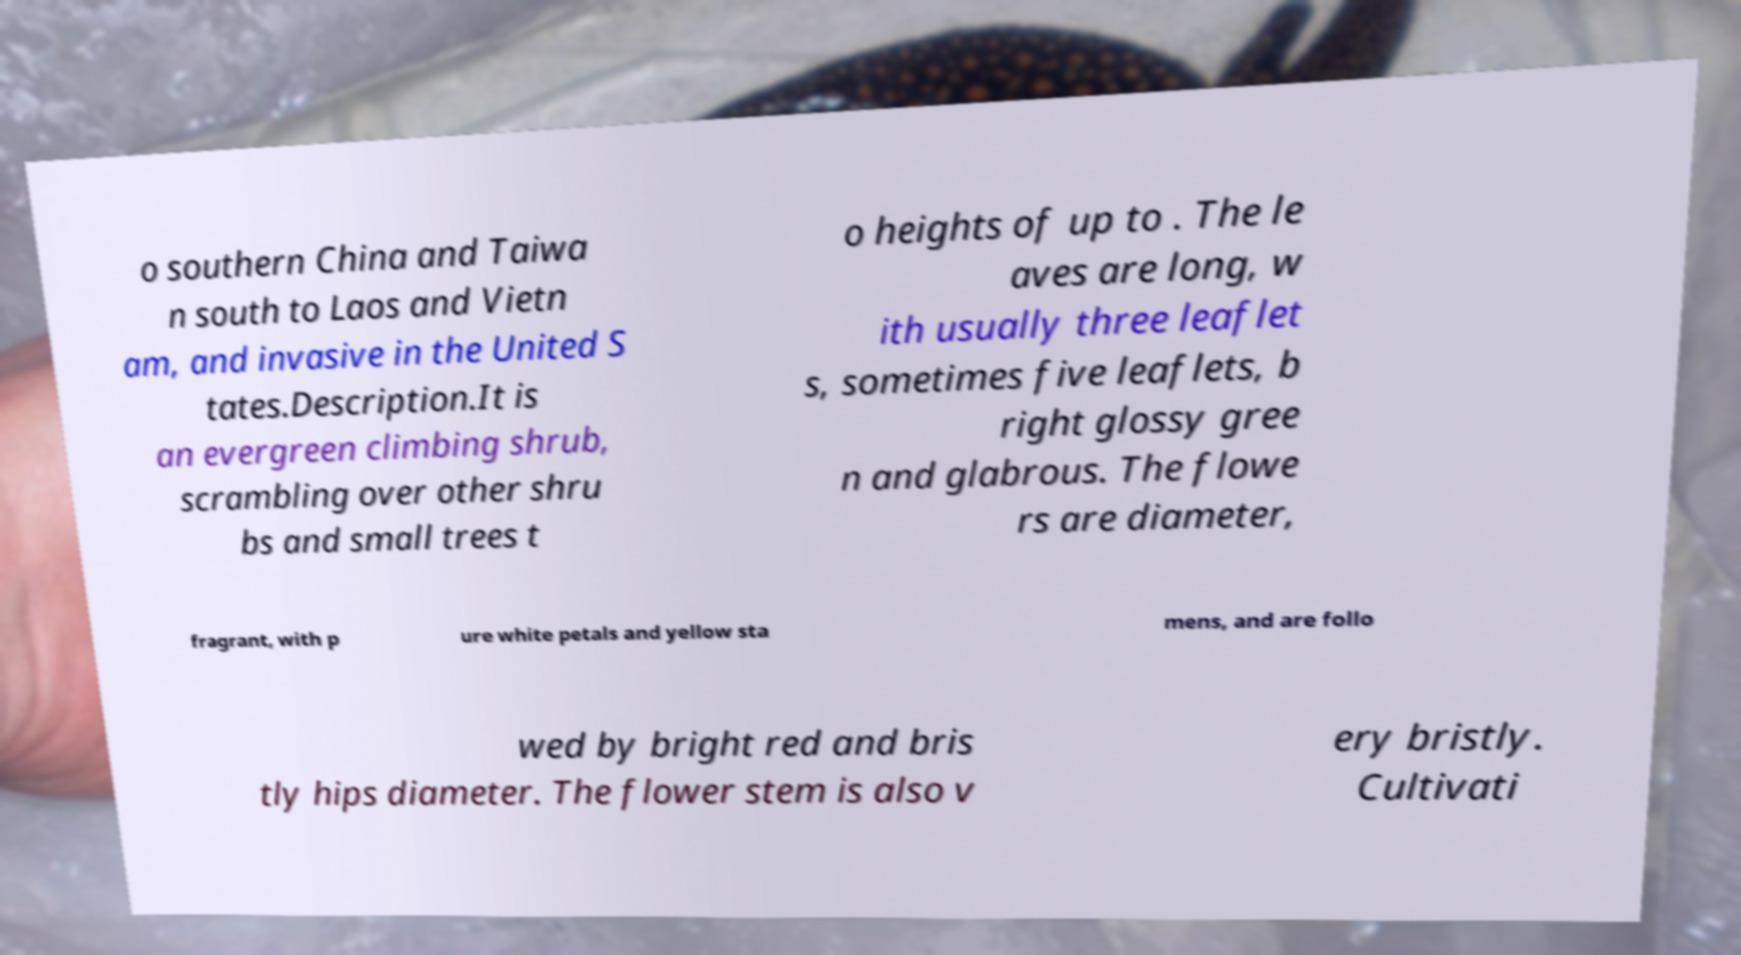Could you assist in decoding the text presented in this image and type it out clearly? o southern China and Taiwa n south to Laos and Vietn am, and invasive in the United S tates.Description.It is an evergreen climbing shrub, scrambling over other shru bs and small trees t o heights of up to . The le aves are long, w ith usually three leaflet s, sometimes five leaflets, b right glossy gree n and glabrous. The flowe rs are diameter, fragrant, with p ure white petals and yellow sta mens, and are follo wed by bright red and bris tly hips diameter. The flower stem is also v ery bristly. Cultivati 